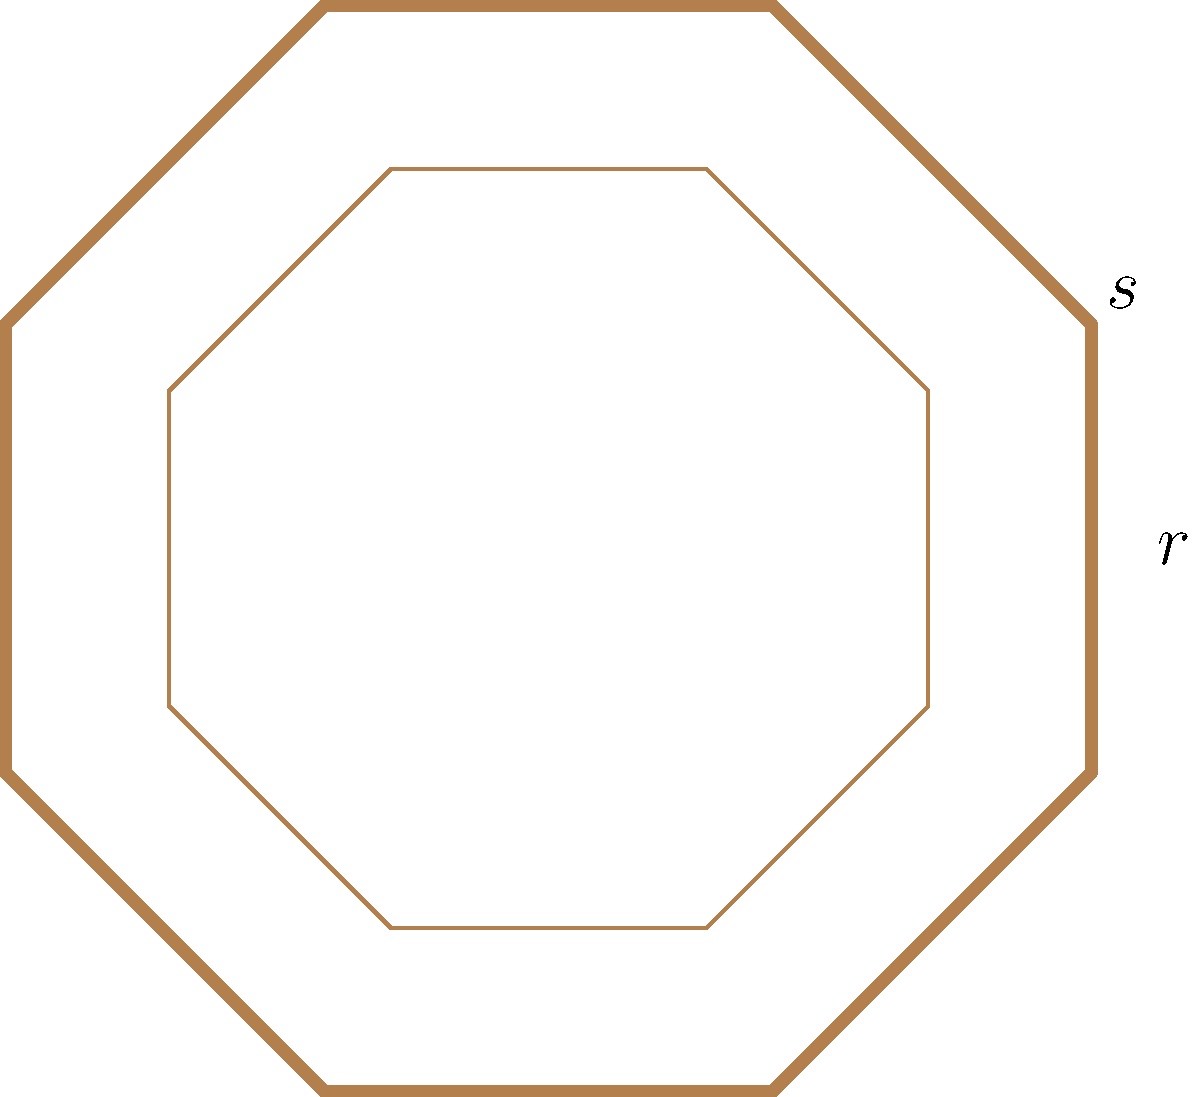Consider the cross-section of a vintage fountain pen's barrel, which has an octagonal shape. This shape can be described by the dihedral group $D_8$. If $r$ represents a 45° clockwise rotation and $s$ represents a reflection across a diagonal, what is the order of the element $rs$ in $D_8$? Let's approach this step-by-step:

1) First, recall that in $D_8$, $r$ is a rotation of 45° clockwise, and $s$ is a reflection.

2) To find the order of $rs$, we need to determine how many times we need to apply $rs$ to get back to the identity element.

3) Let's see what $rs$ does:
   - $s$ reflects the octagon
   - Then $r$ rotates it 45° clockwise

4) Applying $rs$ twice $(rs)^2 = rsrs$:
   - First $rs$: reflect then rotate 45°
   - Second $rs$: reflect (undoing the first rotation) then rotate 45°
   - Net effect: 90° rotation

5) Therefore, $(rs)^2$ is equivalent to $r^2$ (a 90° rotation).

6) We know that in $D_8$, $r^4 = e$ (identity), because a full 360° rotation brings us back to the start.

7) This means that $(rs)^4 = (r^2)^2 = r^4 = e$

8) Therefore, we need to apply $rs$ four times to get back to the identity element.

9) By definition, the order of an element is the smallest positive integer $n$ such that $x^n = e$, where $e$ is the identity element.

Thus, the order of $rs$ in $D_8$ is 4.
Answer: 4 